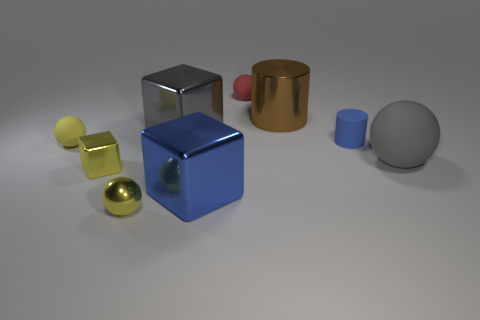There is a big object that is the same color as the matte cylinder; what is it made of?
Provide a short and direct response. Metal. Does the tiny metal cube have the same color as the shiny ball?
Ensure brevity in your answer.  Yes. There is a blue object that is on the right side of the blue cube; how big is it?
Provide a succinct answer. Small. There is a big shiny object that is the same color as the large rubber sphere; what is its shape?
Keep it short and to the point. Cube. Does the tiny blue cylinder have the same material as the big gray block on the left side of the blue cube?
Provide a succinct answer. No. There is a small matte sphere in front of the tiny rubber sphere that is on the right side of the small yellow rubber ball; how many matte balls are to the left of it?
Your answer should be compact. 0. What number of green things are rubber cylinders or tiny metal cubes?
Give a very brief answer. 0. The large gray thing that is right of the red ball has what shape?
Your answer should be compact. Sphere. There is a rubber sphere that is the same size as the brown metallic thing; what color is it?
Keep it short and to the point. Gray. There is a large gray metal thing; is it the same shape as the gray object that is right of the tiny red ball?
Provide a succinct answer. No. 